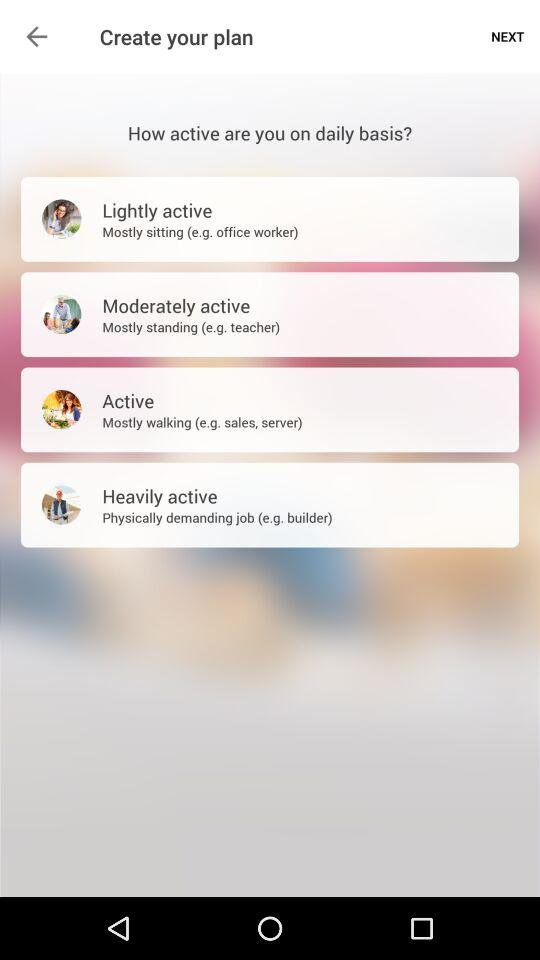How many levels of activity are there?
Answer the question using a single word or phrase. 4 